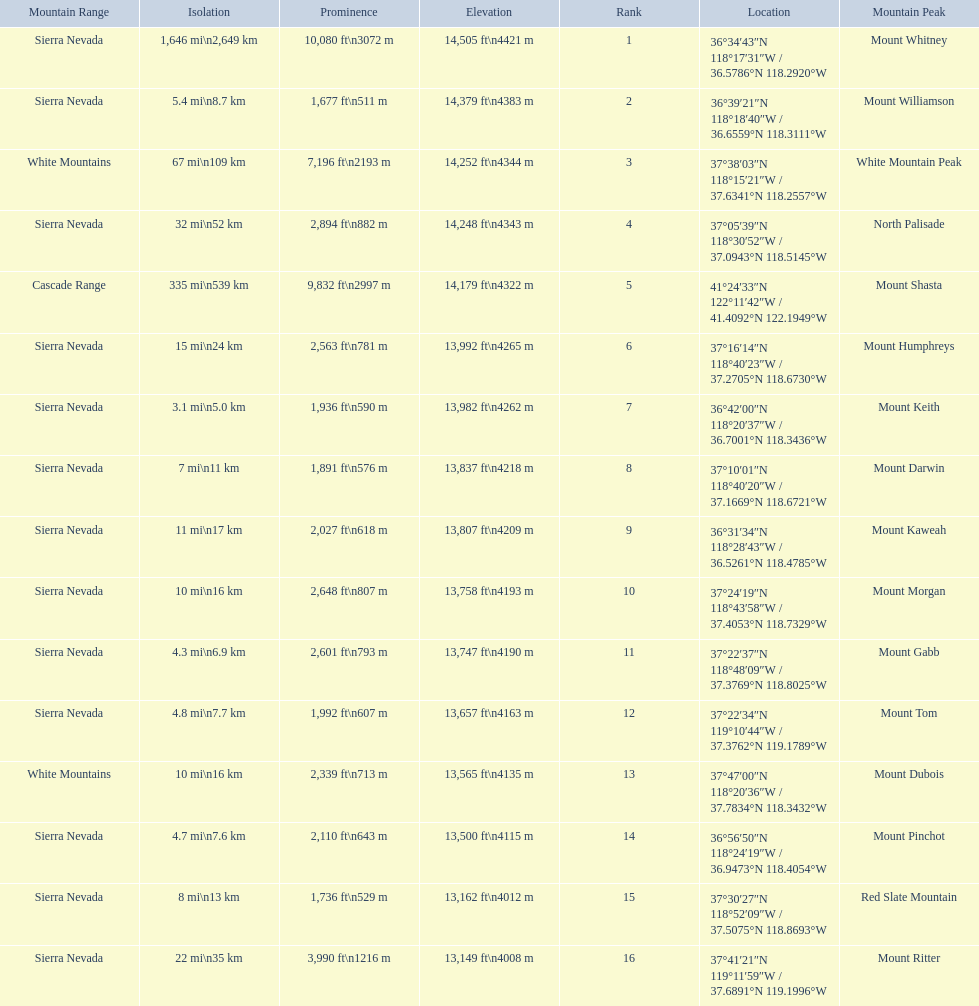What are the heights of the californian mountain peaks? 14,505 ft\n4421 m, 14,379 ft\n4383 m, 14,252 ft\n4344 m, 14,248 ft\n4343 m, 14,179 ft\n4322 m, 13,992 ft\n4265 m, 13,982 ft\n4262 m, 13,837 ft\n4218 m, 13,807 ft\n4209 m, 13,758 ft\n4193 m, 13,747 ft\n4190 m, 13,657 ft\n4163 m, 13,565 ft\n4135 m, 13,500 ft\n4115 m, 13,162 ft\n4012 m, 13,149 ft\n4008 m. What elevation is 13,149 ft or less? 13,149 ft\n4008 m. What mountain peak is at this elevation? Mount Ritter. 